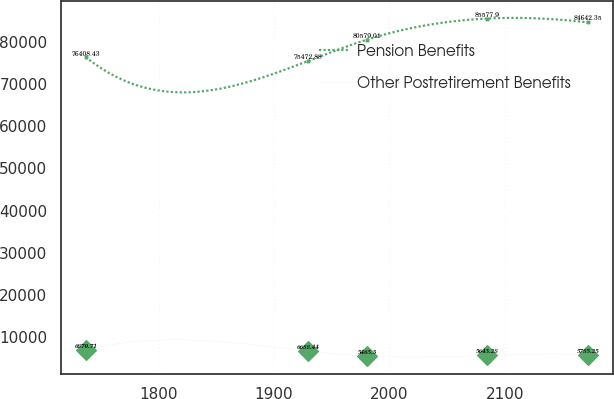Convert chart to OTSL. <chart><loc_0><loc_0><loc_500><loc_500><line_chart><ecel><fcel>Pension Benefits<fcel>Other Postretirement Benefits<nl><fcel>1736.65<fcel>76408.4<fcel>6870.71<nl><fcel>1929.22<fcel>75472.9<fcel>6688.44<nl><fcel>1980.73<fcel>80579<fcel>5465.3<nl><fcel>2085.05<fcel>85577.9<fcel>5643.28<nl><fcel>2172.51<fcel>84642.4<fcel>5785.25<nl></chart> 